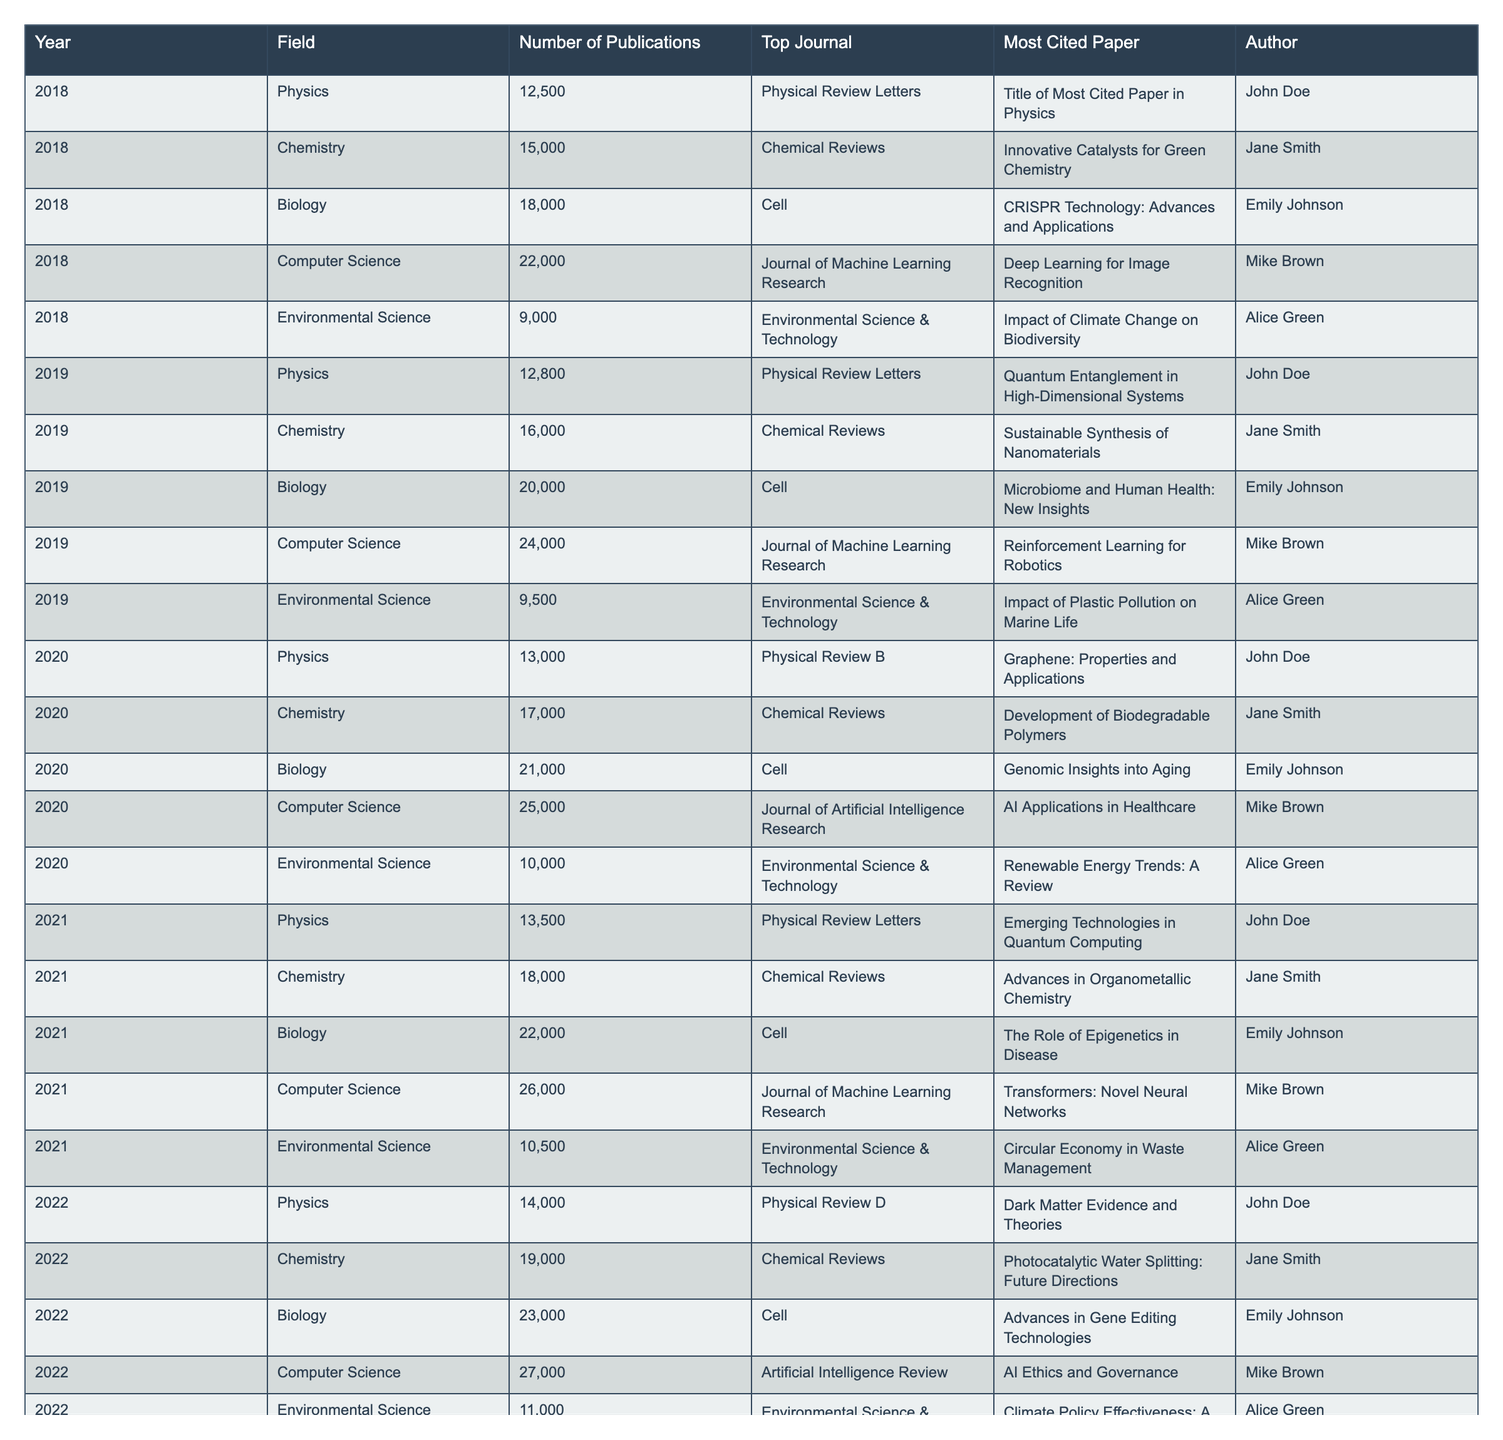What was the top journal in Computer Science in 2023? According to the table, the top journal in Computer Science for the year 2023 is the Journal of Artificial Intelligence Research.
Answer: Journal of Artificial Intelligence Research How many publications were there in Biology in 2021? The table lists the number of publications in Biology for the year 2021 as 22,000.
Answer: 22,000 Which field saw the largest growth in the number of publications from 2020 to 2021? To determine which field had the largest growth, we look at the increase in publications: in 2020, Biology had 21,000 publications, and in 2021 it had 22,000, resulting in a growth of 1,000. For Physics, it went from 13,000 to 13,500 (500 growth). Other fields are similarly assessed. Biology had the highest increase of 1,000 publications from 2020 to 2021.
Answer: Biology What was the most cited paper in Chemistry in 2022? The most cited paper in Chemistry for the year 2022, as per the table, is "Photocatalytic Water Splitting: Future Directions."
Answer: Photocatalytic Water Splitting: Future Directions What was the average number of publications in Environmental Science over the years listed? To find the average for Environmental Science, we total the publications for each year: 9,000 (2018) + 9,500 (2019) + 10,000 (2020) + 10,500 (2021) + 11,000 (2022) + 11,500 (2023) = 61,500. We have six years of data, so the average is 61,500 / 6 = 10,250.
Answer: 10,250 Which author's papers generated more than 20,000 publications in Biology? The table indicates that the author Emily Johnson generated more than 20,000 publications in Biology during the years 2021 (22,000), 2022 (23,000), and 2023 (24,000).
Answer: Emily Johnson In which field was the most cited paper published in 2023? The most cited paper in 2023 was in Biology, titled "Personalized Medicine in Genomics."
Answer: Biology How does the number of publications in Chemistry in 2023 compare to those in 2019? In Chemistry, the number of publications in 2023 is 20,000, while in 2019, it was 16,000. The difference between these two years is 20,000 - 16,000 = 4,000, indicating an increase.
Answer: Increase of 4,000 Was there an increase in the number of publications in Physics every year from 2018 to 2023? Checking the values in the table shows that Physics publications increased each year: 12,500 (2018) to 12,800 (2019), 13,000 (2020), 13,500 (2021), 14,000 (2022), and 14,500 (2023). Every recorded year shows an increase, so the answer is yes.
Answer: Yes What is the total number of publications for Physics from 2018 to 2023? The total number of publications over the years can be summed as follows: 12,500 + 12,800 + 13,000 + 13,500 + 14,000 + 14,500 = 81,300.
Answer: 81,300 Which year had the fewest number of publications in Environmental Science? By examining the table, the year with the fewest number of publications in Environmental Science is 2018 with 9,000 publications.
Answer: 2018 